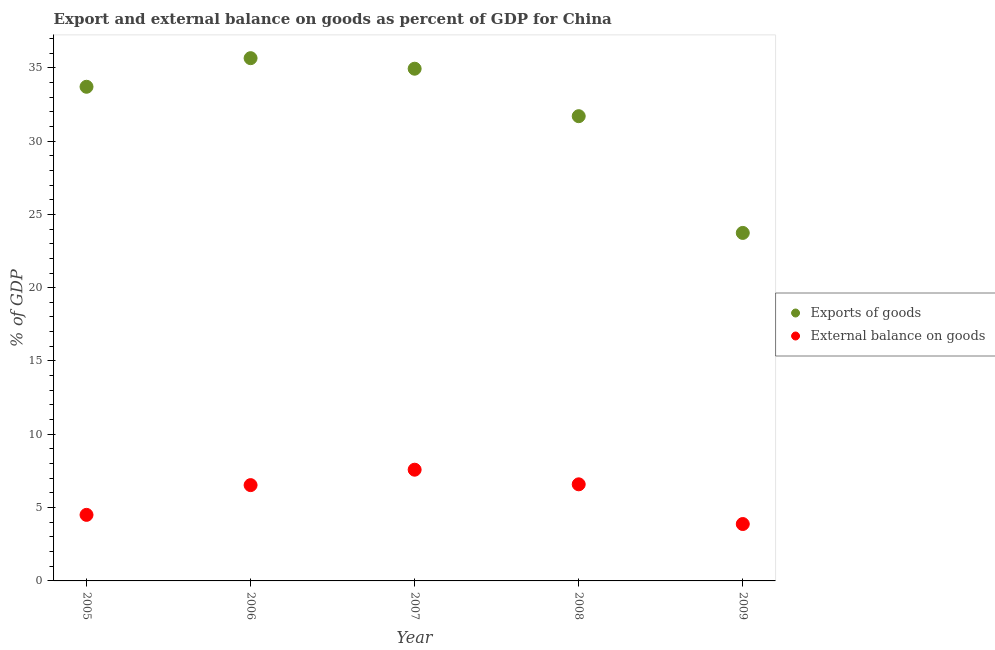Is the number of dotlines equal to the number of legend labels?
Offer a terse response. Yes. What is the external balance on goods as percentage of gdp in 2006?
Give a very brief answer. 6.53. Across all years, what is the maximum export of goods as percentage of gdp?
Provide a short and direct response. 35.65. Across all years, what is the minimum export of goods as percentage of gdp?
Provide a short and direct response. 23.73. In which year was the external balance on goods as percentage of gdp maximum?
Provide a succinct answer. 2007. What is the total export of goods as percentage of gdp in the graph?
Your answer should be very brief. 159.71. What is the difference between the external balance on goods as percentage of gdp in 2006 and that in 2008?
Offer a terse response. -0.05. What is the difference between the export of goods as percentage of gdp in 2007 and the external balance on goods as percentage of gdp in 2005?
Give a very brief answer. 30.43. What is the average export of goods as percentage of gdp per year?
Provide a short and direct response. 31.94. In the year 2009, what is the difference between the export of goods as percentage of gdp and external balance on goods as percentage of gdp?
Make the answer very short. 19.85. In how many years, is the external balance on goods as percentage of gdp greater than 21 %?
Keep it short and to the point. 0. What is the ratio of the external balance on goods as percentage of gdp in 2005 to that in 2008?
Provide a short and direct response. 0.68. Is the difference between the export of goods as percentage of gdp in 2005 and 2008 greater than the difference between the external balance on goods as percentage of gdp in 2005 and 2008?
Give a very brief answer. Yes. What is the difference between the highest and the second highest external balance on goods as percentage of gdp?
Provide a short and direct response. 1. What is the difference between the highest and the lowest external balance on goods as percentage of gdp?
Provide a succinct answer. 3.71. In how many years, is the external balance on goods as percentage of gdp greater than the average external balance on goods as percentage of gdp taken over all years?
Provide a succinct answer. 3. Does the export of goods as percentage of gdp monotonically increase over the years?
Make the answer very short. No. Is the export of goods as percentage of gdp strictly less than the external balance on goods as percentage of gdp over the years?
Provide a succinct answer. No. How many dotlines are there?
Provide a short and direct response. 2. How many years are there in the graph?
Make the answer very short. 5. Does the graph contain any zero values?
Provide a succinct answer. No. Does the graph contain grids?
Offer a terse response. No. Where does the legend appear in the graph?
Keep it short and to the point. Center right. How many legend labels are there?
Offer a terse response. 2. What is the title of the graph?
Make the answer very short. Export and external balance on goods as percent of GDP for China. Does "Forest land" appear as one of the legend labels in the graph?
Offer a very short reply. No. What is the label or title of the X-axis?
Make the answer very short. Year. What is the label or title of the Y-axis?
Your answer should be very brief. % of GDP. What is the % of GDP of Exports of goods in 2005?
Give a very brief answer. 33.7. What is the % of GDP in External balance on goods in 2005?
Offer a very short reply. 4.5. What is the % of GDP of Exports of goods in 2006?
Your answer should be very brief. 35.65. What is the % of GDP in External balance on goods in 2006?
Offer a terse response. 6.53. What is the % of GDP in Exports of goods in 2007?
Your answer should be compact. 34.93. What is the % of GDP of External balance on goods in 2007?
Offer a terse response. 7.59. What is the % of GDP of Exports of goods in 2008?
Offer a very short reply. 31.7. What is the % of GDP of External balance on goods in 2008?
Provide a short and direct response. 6.59. What is the % of GDP in Exports of goods in 2009?
Provide a short and direct response. 23.73. What is the % of GDP of External balance on goods in 2009?
Keep it short and to the point. 3.88. Across all years, what is the maximum % of GDP of Exports of goods?
Offer a very short reply. 35.65. Across all years, what is the maximum % of GDP of External balance on goods?
Keep it short and to the point. 7.59. Across all years, what is the minimum % of GDP of Exports of goods?
Offer a very short reply. 23.73. Across all years, what is the minimum % of GDP of External balance on goods?
Provide a succinct answer. 3.88. What is the total % of GDP in Exports of goods in the graph?
Ensure brevity in your answer.  159.71. What is the total % of GDP in External balance on goods in the graph?
Make the answer very short. 29.09. What is the difference between the % of GDP of Exports of goods in 2005 and that in 2006?
Offer a terse response. -1.95. What is the difference between the % of GDP in External balance on goods in 2005 and that in 2006?
Offer a very short reply. -2.03. What is the difference between the % of GDP in Exports of goods in 2005 and that in 2007?
Provide a succinct answer. -1.23. What is the difference between the % of GDP in External balance on goods in 2005 and that in 2007?
Give a very brief answer. -3.08. What is the difference between the % of GDP in Exports of goods in 2005 and that in 2008?
Offer a terse response. 2.01. What is the difference between the % of GDP of External balance on goods in 2005 and that in 2008?
Provide a short and direct response. -2.08. What is the difference between the % of GDP of Exports of goods in 2005 and that in 2009?
Offer a very short reply. 9.97. What is the difference between the % of GDP in External balance on goods in 2005 and that in 2009?
Your answer should be very brief. 0.62. What is the difference between the % of GDP of Exports of goods in 2006 and that in 2007?
Offer a terse response. 0.72. What is the difference between the % of GDP in External balance on goods in 2006 and that in 2007?
Your response must be concise. -1.05. What is the difference between the % of GDP in Exports of goods in 2006 and that in 2008?
Make the answer very short. 3.96. What is the difference between the % of GDP of External balance on goods in 2006 and that in 2008?
Provide a short and direct response. -0.05. What is the difference between the % of GDP of Exports of goods in 2006 and that in 2009?
Keep it short and to the point. 11.92. What is the difference between the % of GDP in External balance on goods in 2006 and that in 2009?
Make the answer very short. 2.65. What is the difference between the % of GDP of Exports of goods in 2007 and that in 2008?
Give a very brief answer. 3.24. What is the difference between the % of GDP in Exports of goods in 2007 and that in 2009?
Give a very brief answer. 11.2. What is the difference between the % of GDP in External balance on goods in 2007 and that in 2009?
Provide a short and direct response. 3.71. What is the difference between the % of GDP in Exports of goods in 2008 and that in 2009?
Your response must be concise. 7.96. What is the difference between the % of GDP of External balance on goods in 2008 and that in 2009?
Your answer should be very brief. 2.71. What is the difference between the % of GDP of Exports of goods in 2005 and the % of GDP of External balance on goods in 2006?
Offer a terse response. 27.17. What is the difference between the % of GDP of Exports of goods in 2005 and the % of GDP of External balance on goods in 2007?
Keep it short and to the point. 26.12. What is the difference between the % of GDP in Exports of goods in 2005 and the % of GDP in External balance on goods in 2008?
Provide a short and direct response. 27.11. What is the difference between the % of GDP in Exports of goods in 2005 and the % of GDP in External balance on goods in 2009?
Your answer should be compact. 29.82. What is the difference between the % of GDP of Exports of goods in 2006 and the % of GDP of External balance on goods in 2007?
Your answer should be compact. 28.07. What is the difference between the % of GDP in Exports of goods in 2006 and the % of GDP in External balance on goods in 2008?
Offer a terse response. 29.06. What is the difference between the % of GDP in Exports of goods in 2006 and the % of GDP in External balance on goods in 2009?
Your answer should be compact. 31.77. What is the difference between the % of GDP of Exports of goods in 2007 and the % of GDP of External balance on goods in 2008?
Keep it short and to the point. 28.34. What is the difference between the % of GDP of Exports of goods in 2007 and the % of GDP of External balance on goods in 2009?
Your answer should be very brief. 31.05. What is the difference between the % of GDP of Exports of goods in 2008 and the % of GDP of External balance on goods in 2009?
Your answer should be compact. 27.81. What is the average % of GDP in Exports of goods per year?
Make the answer very short. 31.94. What is the average % of GDP of External balance on goods per year?
Your answer should be very brief. 5.82. In the year 2005, what is the difference between the % of GDP of Exports of goods and % of GDP of External balance on goods?
Keep it short and to the point. 29.2. In the year 2006, what is the difference between the % of GDP in Exports of goods and % of GDP in External balance on goods?
Offer a very short reply. 29.12. In the year 2007, what is the difference between the % of GDP of Exports of goods and % of GDP of External balance on goods?
Give a very brief answer. 27.35. In the year 2008, what is the difference between the % of GDP in Exports of goods and % of GDP in External balance on goods?
Give a very brief answer. 25.11. In the year 2009, what is the difference between the % of GDP in Exports of goods and % of GDP in External balance on goods?
Give a very brief answer. 19.85. What is the ratio of the % of GDP of Exports of goods in 2005 to that in 2006?
Keep it short and to the point. 0.95. What is the ratio of the % of GDP in External balance on goods in 2005 to that in 2006?
Your answer should be compact. 0.69. What is the ratio of the % of GDP in Exports of goods in 2005 to that in 2007?
Your answer should be compact. 0.96. What is the ratio of the % of GDP in External balance on goods in 2005 to that in 2007?
Provide a succinct answer. 0.59. What is the ratio of the % of GDP of Exports of goods in 2005 to that in 2008?
Offer a terse response. 1.06. What is the ratio of the % of GDP of External balance on goods in 2005 to that in 2008?
Ensure brevity in your answer.  0.68. What is the ratio of the % of GDP in Exports of goods in 2005 to that in 2009?
Your answer should be compact. 1.42. What is the ratio of the % of GDP in External balance on goods in 2005 to that in 2009?
Provide a succinct answer. 1.16. What is the ratio of the % of GDP of Exports of goods in 2006 to that in 2007?
Your answer should be very brief. 1.02. What is the ratio of the % of GDP in External balance on goods in 2006 to that in 2007?
Your answer should be very brief. 0.86. What is the ratio of the % of GDP in Exports of goods in 2006 to that in 2008?
Your answer should be very brief. 1.12. What is the ratio of the % of GDP in External balance on goods in 2006 to that in 2008?
Make the answer very short. 0.99. What is the ratio of the % of GDP in Exports of goods in 2006 to that in 2009?
Your response must be concise. 1.5. What is the ratio of the % of GDP in External balance on goods in 2006 to that in 2009?
Provide a succinct answer. 1.68. What is the ratio of the % of GDP in Exports of goods in 2007 to that in 2008?
Your answer should be compact. 1.1. What is the ratio of the % of GDP of External balance on goods in 2007 to that in 2008?
Give a very brief answer. 1.15. What is the ratio of the % of GDP in Exports of goods in 2007 to that in 2009?
Provide a succinct answer. 1.47. What is the ratio of the % of GDP in External balance on goods in 2007 to that in 2009?
Offer a very short reply. 1.95. What is the ratio of the % of GDP in Exports of goods in 2008 to that in 2009?
Your answer should be compact. 1.34. What is the ratio of the % of GDP in External balance on goods in 2008 to that in 2009?
Offer a very short reply. 1.7. What is the difference between the highest and the second highest % of GDP of Exports of goods?
Offer a very short reply. 0.72. What is the difference between the highest and the second highest % of GDP in External balance on goods?
Your response must be concise. 1. What is the difference between the highest and the lowest % of GDP in Exports of goods?
Offer a terse response. 11.92. What is the difference between the highest and the lowest % of GDP in External balance on goods?
Ensure brevity in your answer.  3.71. 